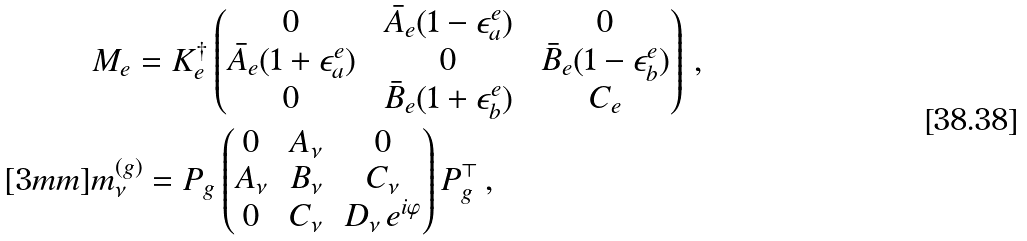<formula> <loc_0><loc_0><loc_500><loc_500>& M _ { e } = K _ { e } ^ { \dagger } \begin{pmatrix} \ 0 \ & \ \bar { A } _ { e } ( 1 - \epsilon _ { a } ^ { e } ) \ & \ 0 \ \\ \bar { A } _ { e } ( 1 + \epsilon _ { a } ^ { e } ) & 0 & \bar { B } _ { e } ( 1 - \epsilon _ { b } ^ { e } ) \\ 0 & \bar { B } _ { e } ( 1 + \epsilon _ { b } ^ { e } ) & C _ { e } \end{pmatrix} \, , \\ [ 3 m m ] & m _ { \nu } ^ { ( g ) } = P _ { g } \begin{pmatrix} \, 0 \, & \, A _ { \nu } \, & 0 \\ A _ { \nu } & B _ { \nu } & C _ { \nu } \\ 0 & C _ { \nu } & D _ { \nu } \, e ^ { i \varphi } \end{pmatrix} P _ { g } ^ { \top } \, ,</formula> 